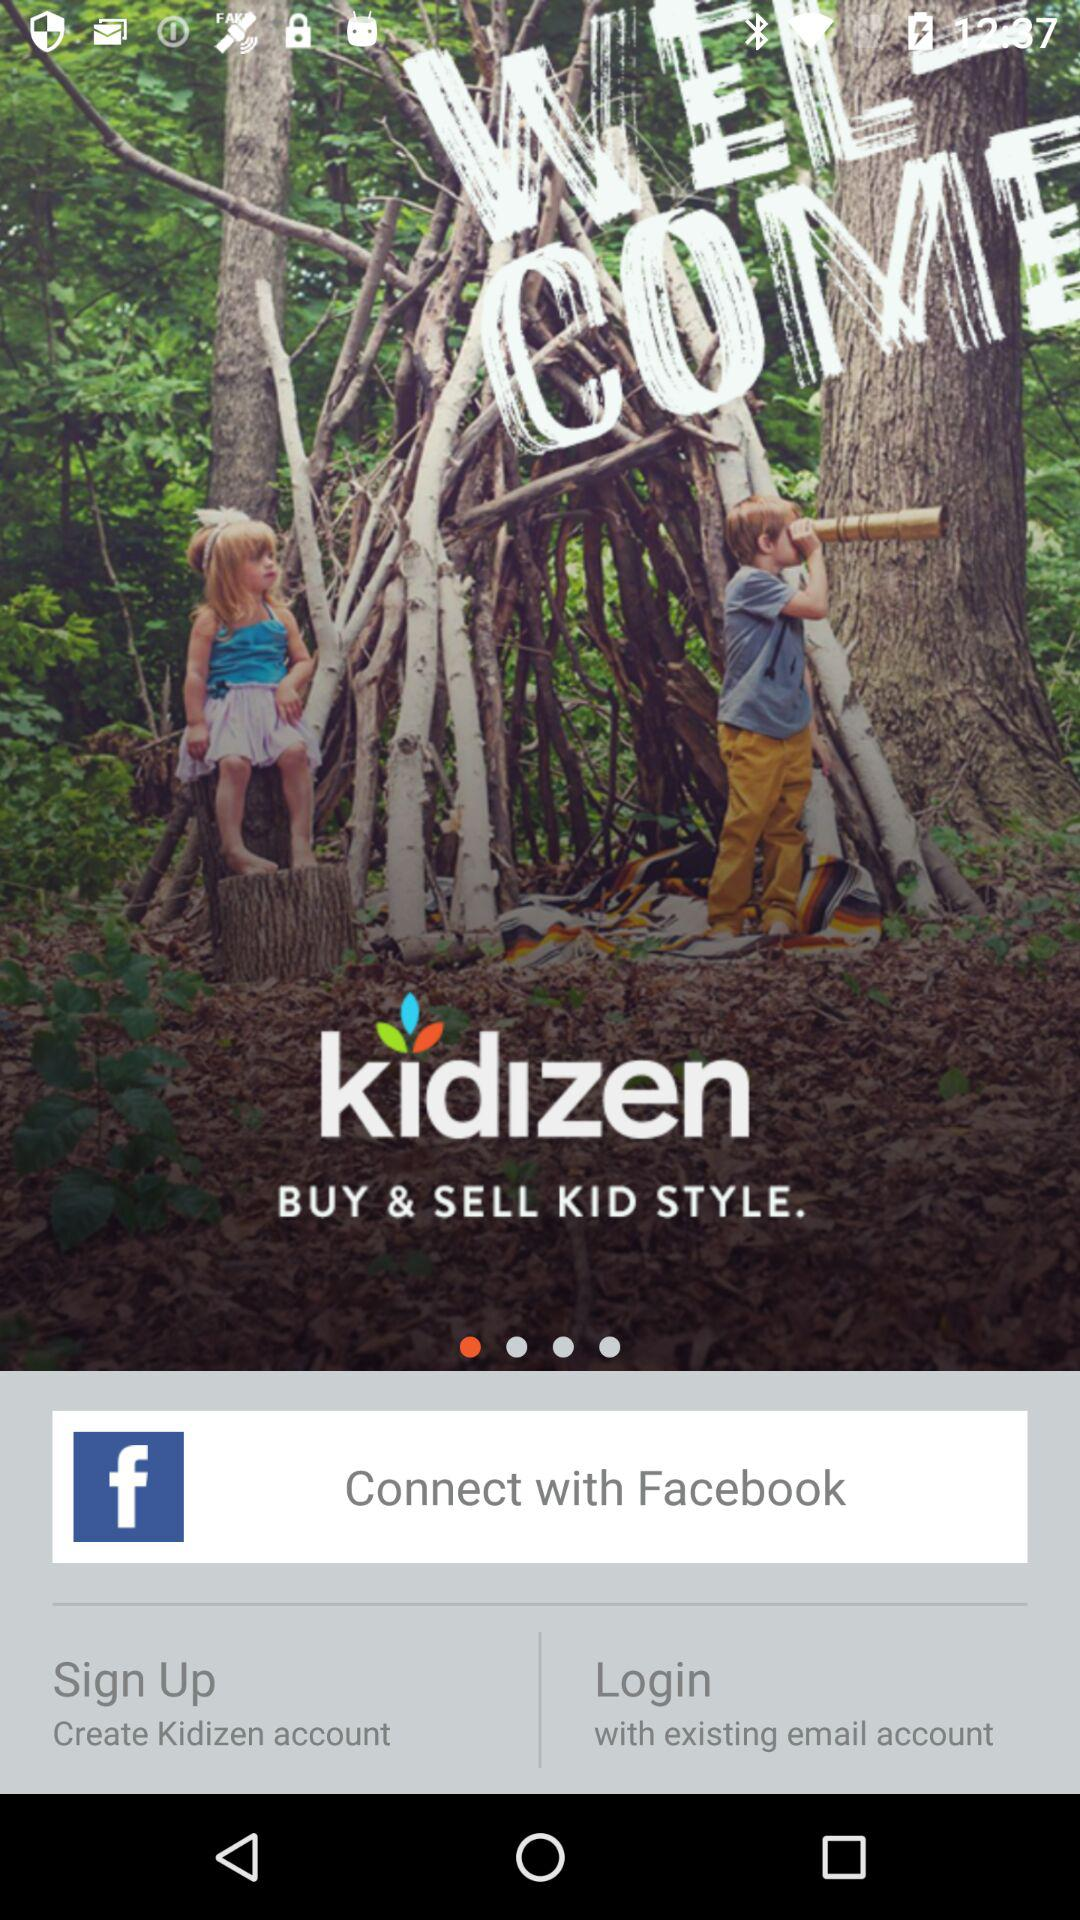Which app can we use to buy and sell kid's clothes? You can use "kidizen" to buy and sell kid's clothes. 